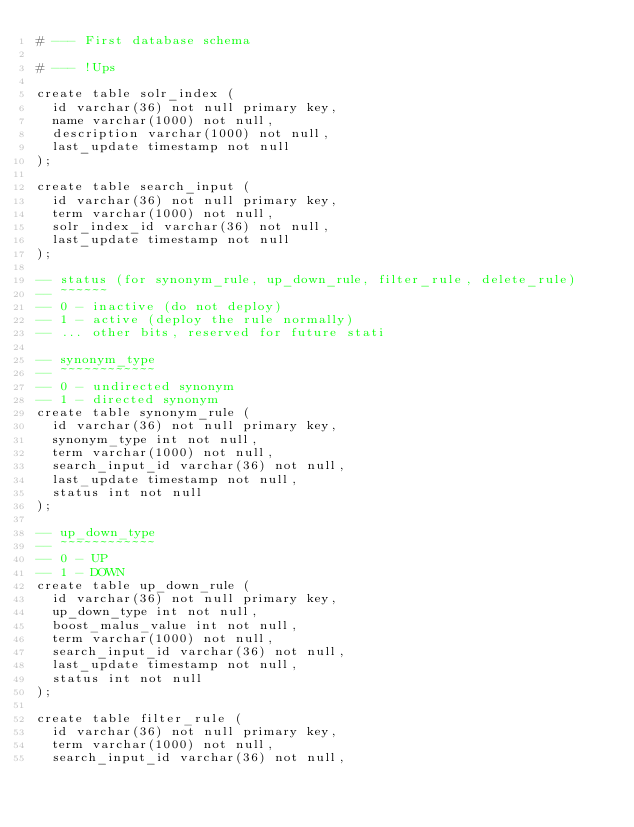Convert code to text. <code><loc_0><loc_0><loc_500><loc_500><_SQL_># --- First database schema

# --- !Ups

create table solr_index (
	id varchar(36) not null primary key,
	name varchar(1000) not null,
	description varchar(1000) not null,
	last_update timestamp not null
);

create table search_input (
	id varchar(36) not null primary key,
	term varchar(1000) not null,
	solr_index_id varchar(36) not null,
	last_update timestamp not null
);

-- status (for synonym_rule, up_down_rule, filter_rule, delete_rule)
-- ~~~~~~
-- 0 - inactive (do not deploy)
-- 1 - active (deploy the rule normally)
-- ... other bits, reserved for future stati

-- synonym_type
-- ~~~~~~~~~~~~
-- 0 - undirected synonym
-- 1 - directed synonym
create table synonym_rule (
	id varchar(36) not null primary key,
	synonym_type int not null,
	term varchar(1000) not null,
	search_input_id varchar(36) not null,
	last_update timestamp not null,
	status int not null
);

-- up_down_type
-- ~~~~~~~~~~~~
-- 0 - UP
-- 1 - DOWN
create table up_down_rule (
	id varchar(36) not null primary key,
	up_down_type int not null,
	boost_malus_value int not null,
	term varchar(1000) not null,
	search_input_id varchar(36) not null,
	last_update timestamp not null,
	status int not null
);

create table filter_rule (
	id varchar(36) not null primary key,
	term varchar(1000) not null,
	search_input_id varchar(36) not null,</code> 